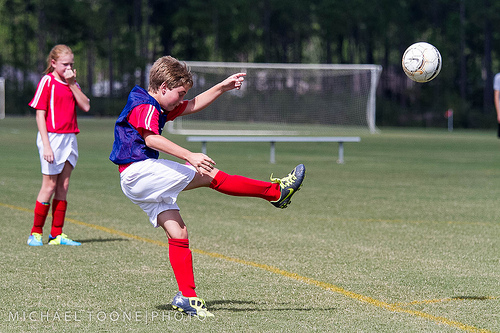<image>
Is there a sock on the field? No. The sock is not positioned on the field. They may be near each other, but the sock is not supported by or resting on top of the field. 